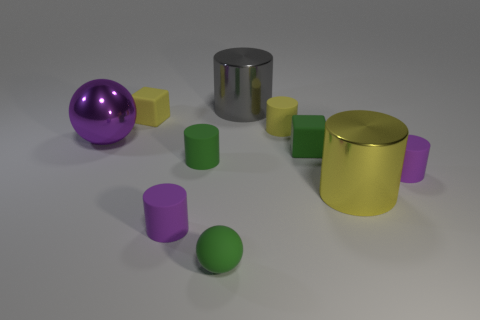Subtract all green cylinders. How many cylinders are left? 5 Subtract all small green cylinders. How many cylinders are left? 5 Subtract all red cylinders. Subtract all gray blocks. How many cylinders are left? 6 Subtract all cylinders. How many objects are left? 4 Subtract all purple cubes. Subtract all yellow cylinders. How many objects are left? 8 Add 7 cubes. How many cubes are left? 9 Add 10 large cubes. How many large cubes exist? 10 Subtract 0 blue cubes. How many objects are left? 10 